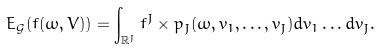<formula> <loc_0><loc_0><loc_500><loc_500>E _ { \mathcal { G } } ( f ( \omega , V ) ) = \int _ { \mathbb { R } ^ { J } } f ^ { J } \times p _ { J } ( \omega , v _ { 1 } , \dots , v _ { J } ) d v _ { 1 } \dots d v _ { J } .</formula> 